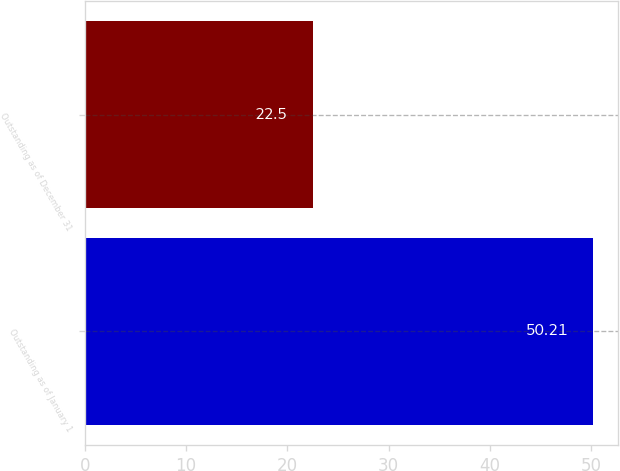Convert chart to OTSL. <chart><loc_0><loc_0><loc_500><loc_500><bar_chart><fcel>Outstanding as of January 1<fcel>Outstanding as of December 31<nl><fcel>50.21<fcel>22.5<nl></chart> 